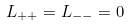<formula> <loc_0><loc_0><loc_500><loc_500>L _ { + + } = L _ { - - } = 0</formula> 